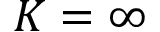Convert formula to latex. <formula><loc_0><loc_0><loc_500><loc_500>K = \infty</formula> 